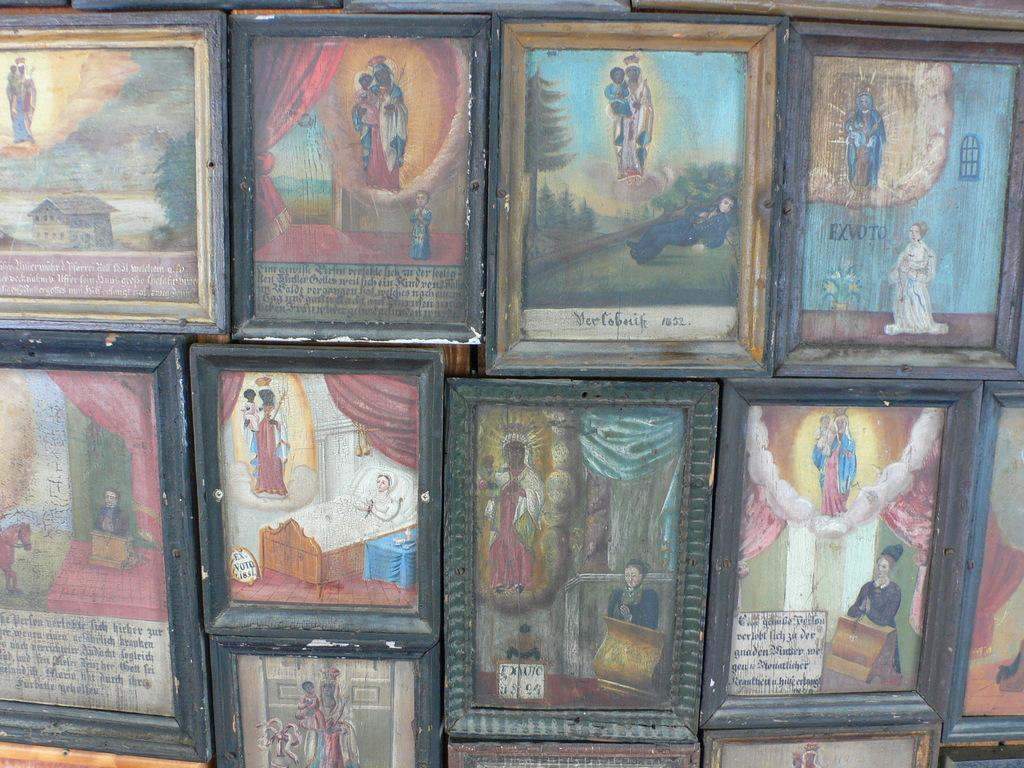Provide a one-sentence caption for the provided image. Paintings have their artist's name on front to signify who created it. 